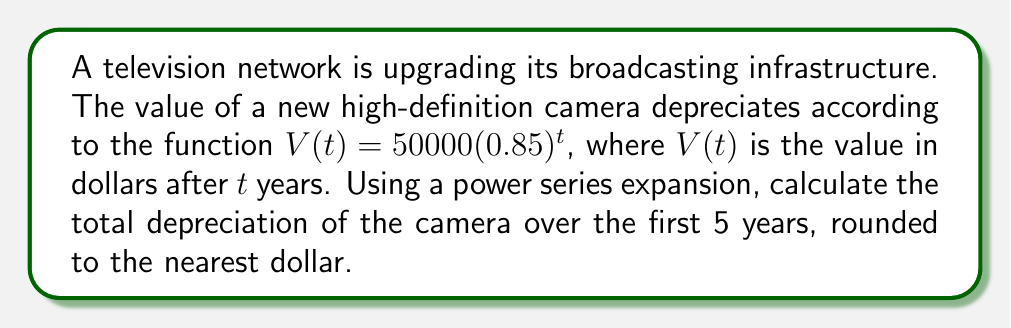Could you help me with this problem? Let's approach this step-by-step:

1) The depreciation function is $V(t) = 50000(0.85)^t$

2) To find the total depreciation over 5 years, we need to calculate $V(0) - V(5)$

3) $V(0) = 50000(0.85)^0 = 50000$

4) To calculate $V(5)$, we'll use the power series expansion of $(0.85)^t$ around $t=0$:

   $$(0.85)^t = 1 + \ln(0.85)t + \frac{(\ln(0.85))^2}{2!}t^2 + \frac{(\ln(0.85))^3}{3!}t^3 + \frac{(\ln(0.85))^4}{4!}t^4 + \frac{(\ln(0.85))^5}{5!}t^5 + ...$$

5) Evaluating at $t=5$ and multiplying by 50000:

   $$V(5) = 50000(1 + 5\ln(0.85) + \frac{25(\ln(0.85))^2}{2} + \frac{125(\ln(0.85))^3}{6} + \frac{625(\ln(0.85))^4}{24} + \frac{3125(\ln(0.85))^5}{120})$$

6) Calculating this (using a calculator or computer):

   $$V(5) \approx 50000(0.4437) = 22185$$

7) The total depreciation is:

   $$V(0) - V(5) = 50000 - 22185 = 27815$$

8) Rounding to the nearest dollar: $27815$
Answer: $27815 